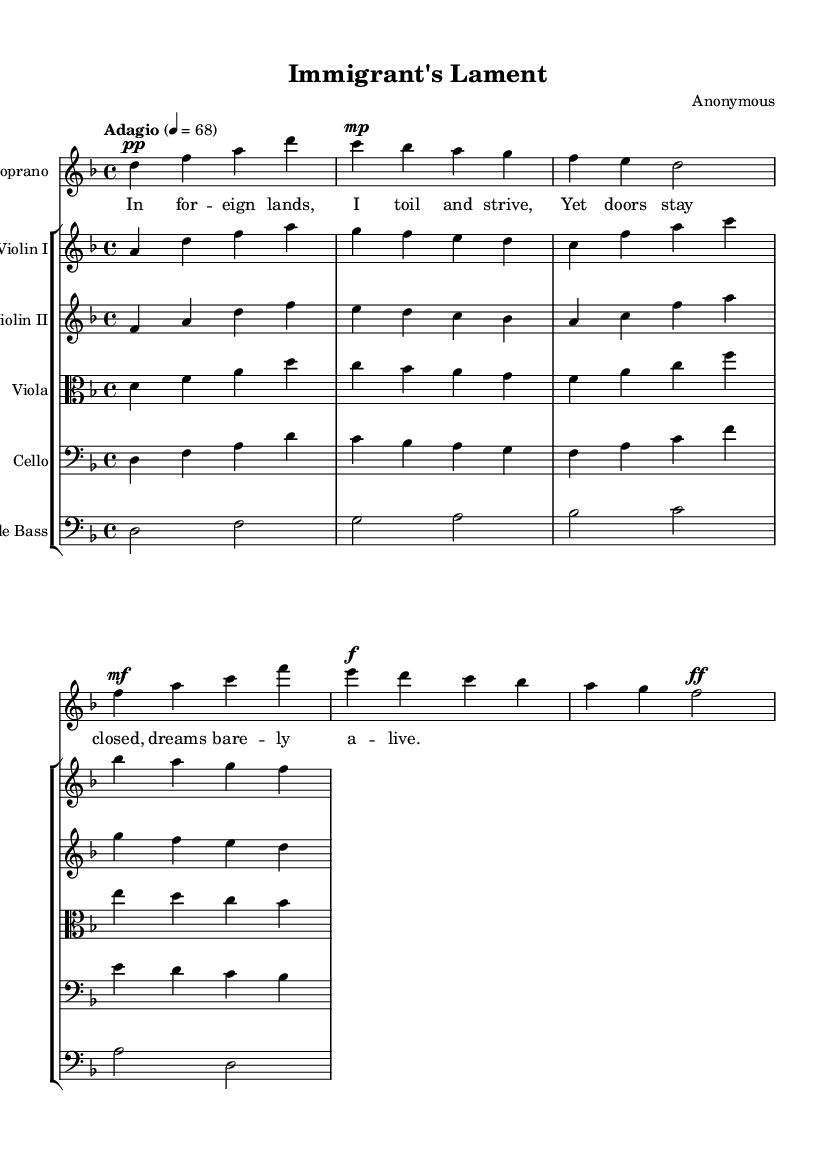What is the key signature of this music? The key signature is indicated by the number of sharps or flats at the beginning of the staff. In this sheet music, there is one flat (B♭), indicating the key signature is D minor.
Answer: D minor What is the time signature of this piece? The time signature is displayed at the beginning of the music. Here, it shows 4/4, meaning there are four beats in each measure and the quarter note gets one beat.
Answer: 4/4 What is the tempo marking for this piece? The tempo marking is written above the staff, indicating the speed of the music. In this score, it states "Adagio" with a metronome marking of 68, which indicates a slow tempo.
Answer: Adagio 4 = 68 How many instruments are included in the score? The score features multiple staves. By counting each staff, we see there is one staff for the soprano voice and five staves for strings, totaling six instruments: soprano, violin I, violin II, viola, cello, and double bass.
Answer: Six What dynamics does the soprano part include? Dynamics are indicated by markings in the vocal part. The soprano part shows "pp" (pianissimo) at the beginning, followed by "mp" (mezzo-piano), "f" (forte), and "ff" (fortissimo) later in the measure, depicting a range of dynamics throughout the piece.
Answer: pp, mp, f, ff What thematic content does the soprano's lyrics express? By examining the lyrics provided with the soprano line, we see the text reflects the experiences and struggles of an immigrant. Phrases like "I toil and strive" and "doors stay closed" emphasize feelings of hardship and frustration.
Answer: Economic struggles and societal change 